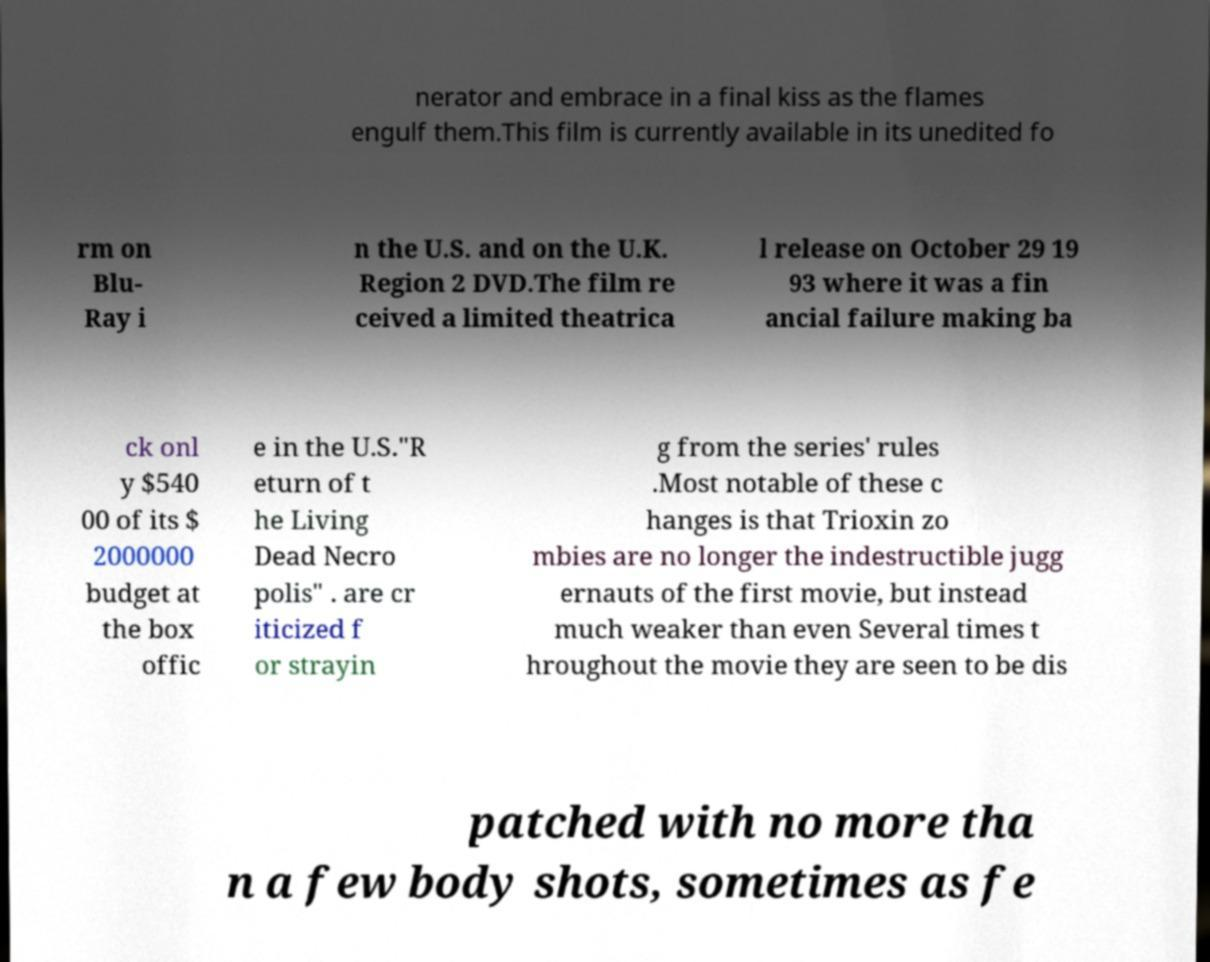What messages or text are displayed in this image? I need them in a readable, typed format. nerator and embrace in a final kiss as the flames engulf them.This film is currently available in its unedited fo rm on Blu- Ray i n the U.S. and on the U.K. Region 2 DVD.The film re ceived a limited theatrica l release on October 29 19 93 where it was a fin ancial failure making ba ck onl y $540 00 of its $ 2000000 budget at the box offic e in the U.S."R eturn of t he Living Dead Necro polis" . are cr iticized f or strayin g from the series' rules .Most notable of these c hanges is that Trioxin zo mbies are no longer the indestructible jugg ernauts of the first movie, but instead much weaker than even Several times t hroughout the movie they are seen to be dis patched with no more tha n a few body shots, sometimes as fe 